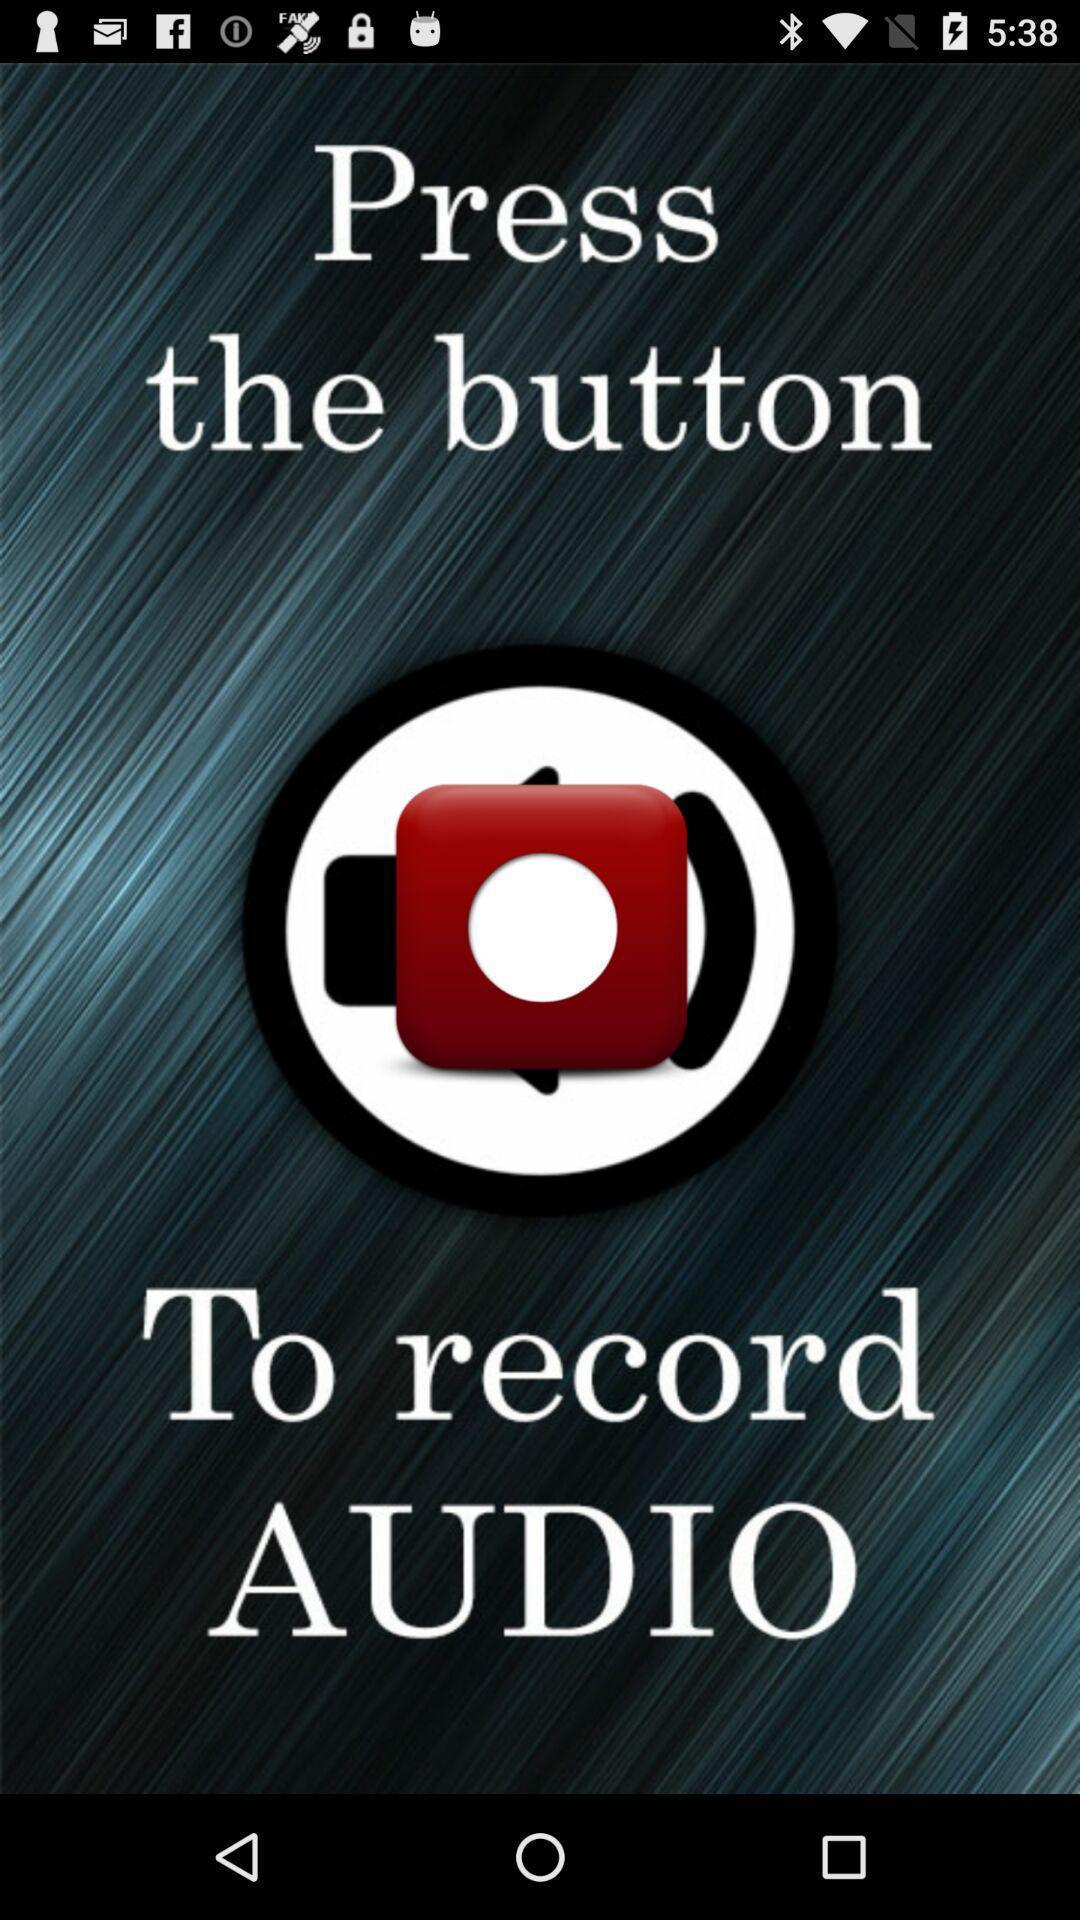Summarize the information in this screenshot. To record audio press button. 